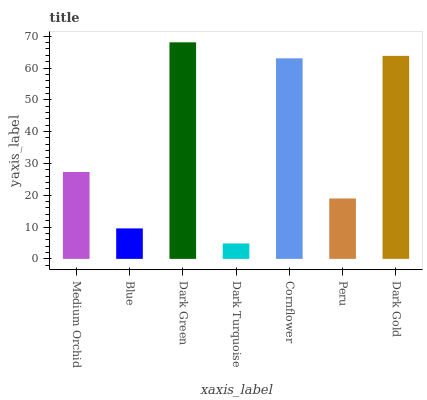Is Dark Turquoise the minimum?
Answer yes or no. Yes. Is Dark Green the maximum?
Answer yes or no. Yes. Is Blue the minimum?
Answer yes or no. No. Is Blue the maximum?
Answer yes or no. No. Is Medium Orchid greater than Blue?
Answer yes or no. Yes. Is Blue less than Medium Orchid?
Answer yes or no. Yes. Is Blue greater than Medium Orchid?
Answer yes or no. No. Is Medium Orchid less than Blue?
Answer yes or no. No. Is Medium Orchid the high median?
Answer yes or no. Yes. Is Medium Orchid the low median?
Answer yes or no. Yes. Is Dark Gold the high median?
Answer yes or no. No. Is Dark Green the low median?
Answer yes or no. No. 